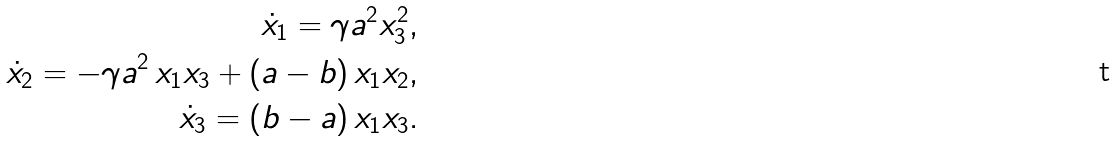<formula> <loc_0><loc_0><loc_500><loc_500>\dot { x } _ { 1 } = \gamma a ^ { 2 } x _ { 3 } ^ { 2 } , \\ \dot { x } _ { 2 } = - \gamma a ^ { 2 } \, x _ { 1 } x _ { 3 } + ( a - b ) \, x _ { 1 } x _ { 2 } , \\ \dot { x } _ { 3 } = ( b - a ) \, x _ { 1 } x _ { 3 } .</formula> 